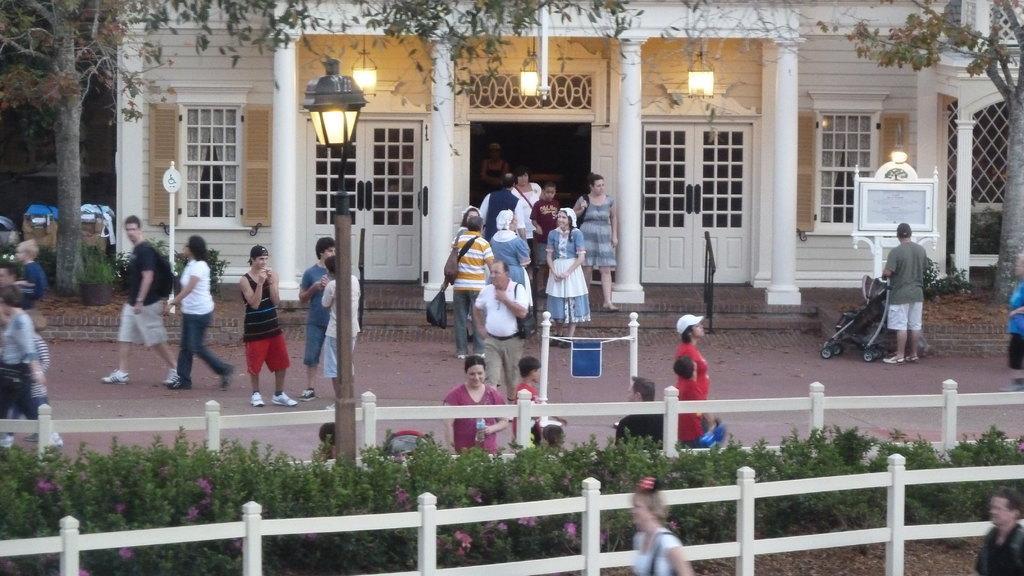Please provide a concise description of this image. In this image we can see many people. Some are wearing caps. There are railings with wooden poles. Also there are plants with flowers. There is a light pole. In the back there are trees. And there is a person standing near to a stroller. In the background there is a building with windows. And there are steps. Also there are pillars and lights. On the left side there are bins. And there is a pot with a plant. 